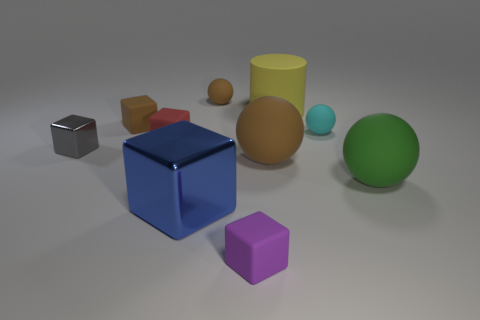Can you tell me the colors of the cubes visible in the picture? Certainly, there are three cubes visible in the picture: one is blue, another is purple, and the third is a brownish-orange or tan color. 